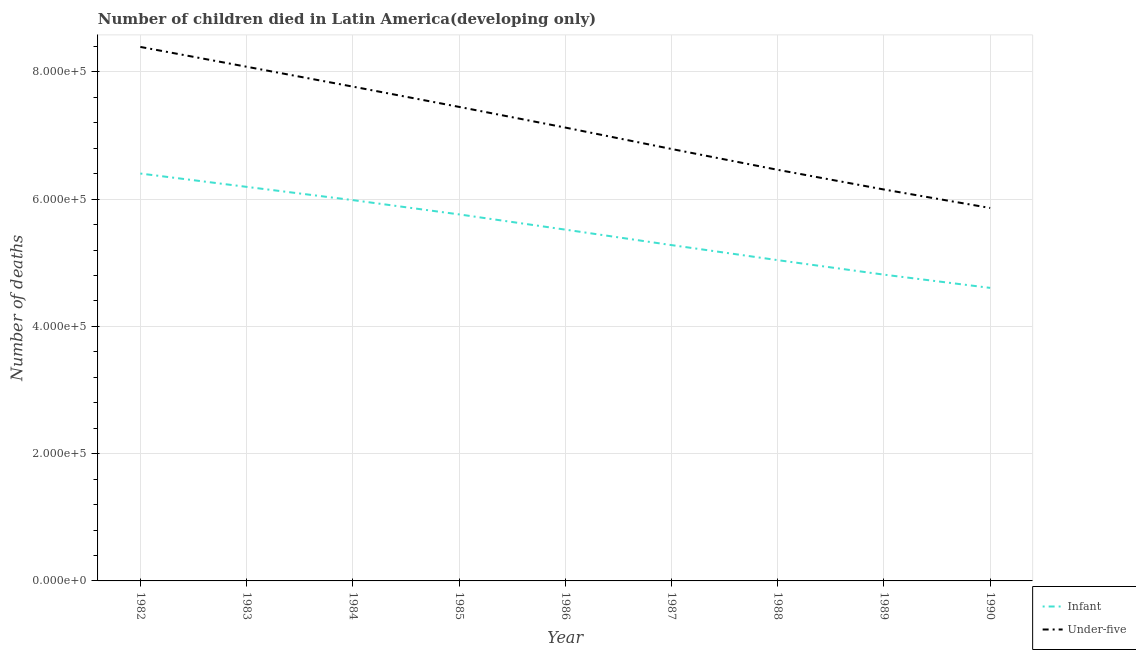How many different coloured lines are there?
Your response must be concise. 2. Does the line corresponding to number of infant deaths intersect with the line corresponding to number of under-five deaths?
Your response must be concise. No. What is the number of infant deaths in 1986?
Provide a short and direct response. 5.52e+05. Across all years, what is the maximum number of under-five deaths?
Offer a very short reply. 8.39e+05. Across all years, what is the minimum number of under-five deaths?
Offer a very short reply. 5.86e+05. In which year was the number of infant deaths minimum?
Provide a short and direct response. 1990. What is the total number of infant deaths in the graph?
Make the answer very short. 4.96e+06. What is the difference between the number of under-five deaths in 1983 and that in 1985?
Offer a terse response. 6.31e+04. What is the difference between the number of infant deaths in 1989 and the number of under-five deaths in 1988?
Give a very brief answer. -1.65e+05. What is the average number of infant deaths per year?
Keep it short and to the point. 5.51e+05. In the year 1984, what is the difference between the number of infant deaths and number of under-five deaths?
Your answer should be compact. -1.78e+05. In how many years, is the number of infant deaths greater than 400000?
Ensure brevity in your answer.  9. What is the ratio of the number of infant deaths in 1986 to that in 1990?
Offer a terse response. 1.2. Is the number of under-five deaths in 1985 less than that in 1988?
Provide a succinct answer. No. Is the difference between the number of under-five deaths in 1983 and 1985 greater than the difference between the number of infant deaths in 1983 and 1985?
Keep it short and to the point. Yes. What is the difference between the highest and the second highest number of under-five deaths?
Provide a succinct answer. 3.11e+04. What is the difference between the highest and the lowest number of under-five deaths?
Your answer should be compact. 2.53e+05. In how many years, is the number of infant deaths greater than the average number of infant deaths taken over all years?
Provide a succinct answer. 5. Does the number of infant deaths monotonically increase over the years?
Your answer should be very brief. No. How many lines are there?
Provide a succinct answer. 2. How many years are there in the graph?
Ensure brevity in your answer.  9. What is the difference between two consecutive major ticks on the Y-axis?
Offer a terse response. 2.00e+05. Are the values on the major ticks of Y-axis written in scientific E-notation?
Ensure brevity in your answer.  Yes. What is the title of the graph?
Ensure brevity in your answer.  Number of children died in Latin America(developing only). Does "Diesel" appear as one of the legend labels in the graph?
Ensure brevity in your answer.  No. What is the label or title of the X-axis?
Provide a succinct answer. Year. What is the label or title of the Y-axis?
Give a very brief answer. Number of deaths. What is the Number of deaths in Infant in 1982?
Offer a very short reply. 6.40e+05. What is the Number of deaths in Under-five in 1982?
Provide a short and direct response. 8.39e+05. What is the Number of deaths of Infant in 1983?
Keep it short and to the point. 6.19e+05. What is the Number of deaths of Under-five in 1983?
Provide a succinct answer. 8.08e+05. What is the Number of deaths in Infant in 1984?
Your answer should be very brief. 5.98e+05. What is the Number of deaths of Under-five in 1984?
Make the answer very short. 7.77e+05. What is the Number of deaths in Infant in 1985?
Your answer should be compact. 5.76e+05. What is the Number of deaths of Under-five in 1985?
Provide a succinct answer. 7.45e+05. What is the Number of deaths of Infant in 1986?
Keep it short and to the point. 5.52e+05. What is the Number of deaths of Under-five in 1986?
Offer a very short reply. 7.12e+05. What is the Number of deaths of Infant in 1987?
Ensure brevity in your answer.  5.28e+05. What is the Number of deaths in Under-five in 1987?
Provide a succinct answer. 6.79e+05. What is the Number of deaths of Infant in 1988?
Provide a short and direct response. 5.04e+05. What is the Number of deaths of Under-five in 1988?
Your response must be concise. 6.46e+05. What is the Number of deaths of Infant in 1989?
Give a very brief answer. 4.81e+05. What is the Number of deaths in Under-five in 1989?
Keep it short and to the point. 6.15e+05. What is the Number of deaths of Infant in 1990?
Offer a very short reply. 4.61e+05. What is the Number of deaths in Under-five in 1990?
Offer a terse response. 5.86e+05. Across all years, what is the maximum Number of deaths of Infant?
Make the answer very short. 6.40e+05. Across all years, what is the maximum Number of deaths in Under-five?
Ensure brevity in your answer.  8.39e+05. Across all years, what is the minimum Number of deaths in Infant?
Give a very brief answer. 4.61e+05. Across all years, what is the minimum Number of deaths of Under-five?
Provide a short and direct response. 5.86e+05. What is the total Number of deaths in Infant in the graph?
Your answer should be very brief. 4.96e+06. What is the total Number of deaths of Under-five in the graph?
Make the answer very short. 6.41e+06. What is the difference between the Number of deaths in Infant in 1982 and that in 1983?
Give a very brief answer. 2.09e+04. What is the difference between the Number of deaths of Under-five in 1982 and that in 1983?
Your answer should be compact. 3.11e+04. What is the difference between the Number of deaths of Infant in 1982 and that in 1984?
Make the answer very short. 4.18e+04. What is the difference between the Number of deaths in Under-five in 1982 and that in 1984?
Offer a very short reply. 6.24e+04. What is the difference between the Number of deaths in Infant in 1982 and that in 1985?
Give a very brief answer. 6.42e+04. What is the difference between the Number of deaths of Under-five in 1982 and that in 1985?
Your answer should be very brief. 9.42e+04. What is the difference between the Number of deaths of Infant in 1982 and that in 1986?
Your response must be concise. 8.81e+04. What is the difference between the Number of deaths in Under-five in 1982 and that in 1986?
Give a very brief answer. 1.27e+05. What is the difference between the Number of deaths of Infant in 1982 and that in 1987?
Your answer should be compact. 1.12e+05. What is the difference between the Number of deaths in Under-five in 1982 and that in 1987?
Keep it short and to the point. 1.60e+05. What is the difference between the Number of deaths of Infant in 1982 and that in 1988?
Ensure brevity in your answer.  1.36e+05. What is the difference between the Number of deaths of Under-five in 1982 and that in 1988?
Offer a terse response. 1.93e+05. What is the difference between the Number of deaths in Infant in 1982 and that in 1989?
Ensure brevity in your answer.  1.59e+05. What is the difference between the Number of deaths of Under-five in 1982 and that in 1989?
Offer a terse response. 2.24e+05. What is the difference between the Number of deaths in Infant in 1982 and that in 1990?
Provide a short and direct response. 1.80e+05. What is the difference between the Number of deaths of Under-five in 1982 and that in 1990?
Your answer should be very brief. 2.53e+05. What is the difference between the Number of deaths in Infant in 1983 and that in 1984?
Keep it short and to the point. 2.08e+04. What is the difference between the Number of deaths of Under-five in 1983 and that in 1984?
Offer a very short reply. 3.12e+04. What is the difference between the Number of deaths in Infant in 1983 and that in 1985?
Ensure brevity in your answer.  4.33e+04. What is the difference between the Number of deaths of Under-five in 1983 and that in 1985?
Give a very brief answer. 6.31e+04. What is the difference between the Number of deaths of Infant in 1983 and that in 1986?
Your answer should be very brief. 6.72e+04. What is the difference between the Number of deaths of Under-five in 1983 and that in 1986?
Provide a short and direct response. 9.56e+04. What is the difference between the Number of deaths of Infant in 1983 and that in 1987?
Keep it short and to the point. 9.15e+04. What is the difference between the Number of deaths of Under-five in 1983 and that in 1987?
Ensure brevity in your answer.  1.29e+05. What is the difference between the Number of deaths in Infant in 1983 and that in 1988?
Provide a succinct answer. 1.15e+05. What is the difference between the Number of deaths of Under-five in 1983 and that in 1988?
Your answer should be very brief. 1.62e+05. What is the difference between the Number of deaths in Infant in 1983 and that in 1989?
Your answer should be compact. 1.38e+05. What is the difference between the Number of deaths in Under-five in 1983 and that in 1989?
Your answer should be compact. 1.93e+05. What is the difference between the Number of deaths of Infant in 1983 and that in 1990?
Keep it short and to the point. 1.59e+05. What is the difference between the Number of deaths in Under-five in 1983 and that in 1990?
Make the answer very short. 2.22e+05. What is the difference between the Number of deaths of Infant in 1984 and that in 1985?
Your response must be concise. 2.24e+04. What is the difference between the Number of deaths in Under-five in 1984 and that in 1985?
Your answer should be very brief. 3.19e+04. What is the difference between the Number of deaths of Infant in 1984 and that in 1986?
Provide a short and direct response. 4.64e+04. What is the difference between the Number of deaths of Under-five in 1984 and that in 1986?
Your response must be concise. 6.44e+04. What is the difference between the Number of deaths of Infant in 1984 and that in 1987?
Your response must be concise. 7.07e+04. What is the difference between the Number of deaths in Under-five in 1984 and that in 1987?
Your response must be concise. 9.80e+04. What is the difference between the Number of deaths in Infant in 1984 and that in 1988?
Make the answer very short. 9.43e+04. What is the difference between the Number of deaths of Under-five in 1984 and that in 1988?
Keep it short and to the point. 1.31e+05. What is the difference between the Number of deaths in Infant in 1984 and that in 1989?
Provide a short and direct response. 1.17e+05. What is the difference between the Number of deaths in Under-five in 1984 and that in 1989?
Your answer should be compact. 1.62e+05. What is the difference between the Number of deaths of Infant in 1984 and that in 1990?
Your answer should be compact. 1.38e+05. What is the difference between the Number of deaths in Under-five in 1984 and that in 1990?
Your response must be concise. 1.91e+05. What is the difference between the Number of deaths of Infant in 1985 and that in 1986?
Provide a succinct answer. 2.39e+04. What is the difference between the Number of deaths of Under-five in 1985 and that in 1986?
Provide a short and direct response. 3.25e+04. What is the difference between the Number of deaths of Infant in 1985 and that in 1987?
Provide a succinct answer. 4.83e+04. What is the difference between the Number of deaths in Under-five in 1985 and that in 1987?
Offer a terse response. 6.62e+04. What is the difference between the Number of deaths in Infant in 1985 and that in 1988?
Ensure brevity in your answer.  7.19e+04. What is the difference between the Number of deaths in Under-five in 1985 and that in 1988?
Your answer should be very brief. 9.89e+04. What is the difference between the Number of deaths in Infant in 1985 and that in 1989?
Provide a short and direct response. 9.47e+04. What is the difference between the Number of deaths of Under-five in 1985 and that in 1989?
Keep it short and to the point. 1.30e+05. What is the difference between the Number of deaths of Infant in 1985 and that in 1990?
Offer a terse response. 1.16e+05. What is the difference between the Number of deaths of Under-five in 1985 and that in 1990?
Your answer should be compact. 1.59e+05. What is the difference between the Number of deaths in Infant in 1986 and that in 1987?
Give a very brief answer. 2.43e+04. What is the difference between the Number of deaths of Under-five in 1986 and that in 1987?
Provide a short and direct response. 3.37e+04. What is the difference between the Number of deaths in Infant in 1986 and that in 1988?
Your response must be concise. 4.80e+04. What is the difference between the Number of deaths in Under-five in 1986 and that in 1988?
Provide a succinct answer. 6.64e+04. What is the difference between the Number of deaths of Infant in 1986 and that in 1989?
Provide a short and direct response. 7.08e+04. What is the difference between the Number of deaths of Under-five in 1986 and that in 1989?
Provide a short and direct response. 9.73e+04. What is the difference between the Number of deaths of Infant in 1986 and that in 1990?
Offer a terse response. 9.16e+04. What is the difference between the Number of deaths in Under-five in 1986 and that in 1990?
Make the answer very short. 1.26e+05. What is the difference between the Number of deaths in Infant in 1987 and that in 1988?
Provide a succinct answer. 2.36e+04. What is the difference between the Number of deaths in Under-five in 1987 and that in 1988?
Keep it short and to the point. 3.27e+04. What is the difference between the Number of deaths in Infant in 1987 and that in 1989?
Provide a succinct answer. 4.64e+04. What is the difference between the Number of deaths in Under-five in 1987 and that in 1989?
Your answer should be compact. 6.37e+04. What is the difference between the Number of deaths of Infant in 1987 and that in 1990?
Provide a succinct answer. 6.72e+04. What is the difference between the Number of deaths in Under-five in 1987 and that in 1990?
Offer a very short reply. 9.27e+04. What is the difference between the Number of deaths in Infant in 1988 and that in 1989?
Offer a very short reply. 2.28e+04. What is the difference between the Number of deaths in Under-five in 1988 and that in 1989?
Your response must be concise. 3.09e+04. What is the difference between the Number of deaths in Infant in 1988 and that in 1990?
Ensure brevity in your answer.  4.36e+04. What is the difference between the Number of deaths in Under-five in 1988 and that in 1990?
Provide a short and direct response. 6.00e+04. What is the difference between the Number of deaths of Infant in 1989 and that in 1990?
Make the answer very short. 2.08e+04. What is the difference between the Number of deaths in Under-five in 1989 and that in 1990?
Your answer should be very brief. 2.90e+04. What is the difference between the Number of deaths of Infant in 1982 and the Number of deaths of Under-five in 1983?
Offer a very short reply. -1.68e+05. What is the difference between the Number of deaths of Infant in 1982 and the Number of deaths of Under-five in 1984?
Ensure brevity in your answer.  -1.37e+05. What is the difference between the Number of deaths in Infant in 1982 and the Number of deaths in Under-five in 1985?
Make the answer very short. -1.05e+05. What is the difference between the Number of deaths in Infant in 1982 and the Number of deaths in Under-five in 1986?
Provide a short and direct response. -7.22e+04. What is the difference between the Number of deaths of Infant in 1982 and the Number of deaths of Under-five in 1987?
Your response must be concise. -3.86e+04. What is the difference between the Number of deaths of Infant in 1982 and the Number of deaths of Under-five in 1988?
Give a very brief answer. -5852. What is the difference between the Number of deaths in Infant in 1982 and the Number of deaths in Under-five in 1989?
Keep it short and to the point. 2.51e+04. What is the difference between the Number of deaths of Infant in 1982 and the Number of deaths of Under-five in 1990?
Give a very brief answer. 5.41e+04. What is the difference between the Number of deaths of Infant in 1983 and the Number of deaths of Under-five in 1984?
Your response must be concise. -1.58e+05. What is the difference between the Number of deaths in Infant in 1983 and the Number of deaths in Under-five in 1985?
Your response must be concise. -1.26e+05. What is the difference between the Number of deaths in Infant in 1983 and the Number of deaths in Under-five in 1986?
Offer a terse response. -9.32e+04. What is the difference between the Number of deaths in Infant in 1983 and the Number of deaths in Under-five in 1987?
Offer a very short reply. -5.95e+04. What is the difference between the Number of deaths in Infant in 1983 and the Number of deaths in Under-five in 1988?
Your response must be concise. -2.68e+04. What is the difference between the Number of deaths in Infant in 1983 and the Number of deaths in Under-five in 1989?
Offer a terse response. 4158. What is the difference between the Number of deaths in Infant in 1983 and the Number of deaths in Under-five in 1990?
Provide a succinct answer. 3.32e+04. What is the difference between the Number of deaths of Infant in 1984 and the Number of deaths of Under-five in 1985?
Give a very brief answer. -1.47e+05. What is the difference between the Number of deaths of Infant in 1984 and the Number of deaths of Under-five in 1986?
Provide a short and direct response. -1.14e+05. What is the difference between the Number of deaths in Infant in 1984 and the Number of deaths in Under-five in 1987?
Your answer should be very brief. -8.03e+04. What is the difference between the Number of deaths of Infant in 1984 and the Number of deaths of Under-five in 1988?
Offer a very short reply. -4.76e+04. What is the difference between the Number of deaths of Infant in 1984 and the Number of deaths of Under-five in 1989?
Keep it short and to the point. -1.67e+04. What is the difference between the Number of deaths in Infant in 1984 and the Number of deaths in Under-five in 1990?
Provide a succinct answer. 1.24e+04. What is the difference between the Number of deaths in Infant in 1985 and the Number of deaths in Under-five in 1986?
Make the answer very short. -1.36e+05. What is the difference between the Number of deaths in Infant in 1985 and the Number of deaths in Under-five in 1987?
Your answer should be compact. -1.03e+05. What is the difference between the Number of deaths of Infant in 1985 and the Number of deaths of Under-five in 1988?
Offer a terse response. -7.00e+04. What is the difference between the Number of deaths in Infant in 1985 and the Number of deaths in Under-five in 1989?
Your answer should be very brief. -3.91e+04. What is the difference between the Number of deaths of Infant in 1985 and the Number of deaths of Under-five in 1990?
Offer a terse response. -1.01e+04. What is the difference between the Number of deaths of Infant in 1986 and the Number of deaths of Under-five in 1987?
Offer a terse response. -1.27e+05. What is the difference between the Number of deaths of Infant in 1986 and the Number of deaths of Under-five in 1988?
Offer a terse response. -9.40e+04. What is the difference between the Number of deaths of Infant in 1986 and the Number of deaths of Under-five in 1989?
Give a very brief answer. -6.30e+04. What is the difference between the Number of deaths in Infant in 1986 and the Number of deaths in Under-five in 1990?
Give a very brief answer. -3.40e+04. What is the difference between the Number of deaths in Infant in 1987 and the Number of deaths in Under-five in 1988?
Give a very brief answer. -1.18e+05. What is the difference between the Number of deaths of Infant in 1987 and the Number of deaths of Under-five in 1989?
Give a very brief answer. -8.74e+04. What is the difference between the Number of deaths of Infant in 1987 and the Number of deaths of Under-five in 1990?
Your answer should be compact. -5.83e+04. What is the difference between the Number of deaths of Infant in 1988 and the Number of deaths of Under-five in 1989?
Your response must be concise. -1.11e+05. What is the difference between the Number of deaths of Infant in 1988 and the Number of deaths of Under-five in 1990?
Give a very brief answer. -8.20e+04. What is the difference between the Number of deaths of Infant in 1989 and the Number of deaths of Under-five in 1990?
Keep it short and to the point. -1.05e+05. What is the average Number of deaths of Infant per year?
Your response must be concise. 5.51e+05. What is the average Number of deaths of Under-five per year?
Give a very brief answer. 7.12e+05. In the year 1982, what is the difference between the Number of deaths in Infant and Number of deaths in Under-five?
Make the answer very short. -1.99e+05. In the year 1983, what is the difference between the Number of deaths in Infant and Number of deaths in Under-five?
Your response must be concise. -1.89e+05. In the year 1984, what is the difference between the Number of deaths in Infant and Number of deaths in Under-five?
Your answer should be very brief. -1.78e+05. In the year 1985, what is the difference between the Number of deaths in Infant and Number of deaths in Under-five?
Provide a succinct answer. -1.69e+05. In the year 1986, what is the difference between the Number of deaths in Infant and Number of deaths in Under-five?
Keep it short and to the point. -1.60e+05. In the year 1987, what is the difference between the Number of deaths in Infant and Number of deaths in Under-five?
Offer a very short reply. -1.51e+05. In the year 1988, what is the difference between the Number of deaths of Infant and Number of deaths of Under-five?
Offer a very short reply. -1.42e+05. In the year 1989, what is the difference between the Number of deaths in Infant and Number of deaths in Under-five?
Your answer should be compact. -1.34e+05. In the year 1990, what is the difference between the Number of deaths of Infant and Number of deaths of Under-five?
Give a very brief answer. -1.26e+05. What is the ratio of the Number of deaths of Infant in 1982 to that in 1983?
Give a very brief answer. 1.03. What is the ratio of the Number of deaths in Infant in 1982 to that in 1984?
Offer a very short reply. 1.07. What is the ratio of the Number of deaths in Under-five in 1982 to that in 1984?
Your answer should be very brief. 1.08. What is the ratio of the Number of deaths of Infant in 1982 to that in 1985?
Your answer should be very brief. 1.11. What is the ratio of the Number of deaths of Under-five in 1982 to that in 1985?
Your answer should be compact. 1.13. What is the ratio of the Number of deaths in Infant in 1982 to that in 1986?
Keep it short and to the point. 1.16. What is the ratio of the Number of deaths in Under-five in 1982 to that in 1986?
Make the answer very short. 1.18. What is the ratio of the Number of deaths of Infant in 1982 to that in 1987?
Your answer should be very brief. 1.21. What is the ratio of the Number of deaths of Under-five in 1982 to that in 1987?
Make the answer very short. 1.24. What is the ratio of the Number of deaths in Infant in 1982 to that in 1988?
Offer a terse response. 1.27. What is the ratio of the Number of deaths of Under-five in 1982 to that in 1988?
Ensure brevity in your answer.  1.3. What is the ratio of the Number of deaths in Infant in 1982 to that in 1989?
Your answer should be compact. 1.33. What is the ratio of the Number of deaths of Under-five in 1982 to that in 1989?
Provide a short and direct response. 1.36. What is the ratio of the Number of deaths of Infant in 1982 to that in 1990?
Give a very brief answer. 1.39. What is the ratio of the Number of deaths of Under-five in 1982 to that in 1990?
Make the answer very short. 1.43. What is the ratio of the Number of deaths of Infant in 1983 to that in 1984?
Provide a succinct answer. 1.03. What is the ratio of the Number of deaths of Under-five in 1983 to that in 1984?
Ensure brevity in your answer.  1.04. What is the ratio of the Number of deaths in Infant in 1983 to that in 1985?
Provide a succinct answer. 1.08. What is the ratio of the Number of deaths of Under-five in 1983 to that in 1985?
Your answer should be compact. 1.08. What is the ratio of the Number of deaths of Infant in 1983 to that in 1986?
Offer a terse response. 1.12. What is the ratio of the Number of deaths in Under-five in 1983 to that in 1986?
Your answer should be very brief. 1.13. What is the ratio of the Number of deaths in Infant in 1983 to that in 1987?
Provide a succinct answer. 1.17. What is the ratio of the Number of deaths in Under-five in 1983 to that in 1987?
Offer a terse response. 1.19. What is the ratio of the Number of deaths of Infant in 1983 to that in 1988?
Ensure brevity in your answer.  1.23. What is the ratio of the Number of deaths in Under-five in 1983 to that in 1988?
Make the answer very short. 1.25. What is the ratio of the Number of deaths in Infant in 1983 to that in 1989?
Ensure brevity in your answer.  1.29. What is the ratio of the Number of deaths in Under-five in 1983 to that in 1989?
Ensure brevity in your answer.  1.31. What is the ratio of the Number of deaths of Infant in 1983 to that in 1990?
Provide a short and direct response. 1.34. What is the ratio of the Number of deaths of Under-five in 1983 to that in 1990?
Offer a terse response. 1.38. What is the ratio of the Number of deaths in Infant in 1984 to that in 1985?
Your answer should be very brief. 1.04. What is the ratio of the Number of deaths in Under-five in 1984 to that in 1985?
Keep it short and to the point. 1.04. What is the ratio of the Number of deaths in Infant in 1984 to that in 1986?
Provide a short and direct response. 1.08. What is the ratio of the Number of deaths in Under-five in 1984 to that in 1986?
Your response must be concise. 1.09. What is the ratio of the Number of deaths of Infant in 1984 to that in 1987?
Ensure brevity in your answer.  1.13. What is the ratio of the Number of deaths of Under-five in 1984 to that in 1987?
Your answer should be compact. 1.14. What is the ratio of the Number of deaths in Infant in 1984 to that in 1988?
Your response must be concise. 1.19. What is the ratio of the Number of deaths of Under-five in 1984 to that in 1988?
Provide a short and direct response. 1.2. What is the ratio of the Number of deaths of Infant in 1984 to that in 1989?
Offer a very short reply. 1.24. What is the ratio of the Number of deaths in Under-five in 1984 to that in 1989?
Your answer should be compact. 1.26. What is the ratio of the Number of deaths of Infant in 1984 to that in 1990?
Your response must be concise. 1.3. What is the ratio of the Number of deaths in Under-five in 1984 to that in 1990?
Your response must be concise. 1.33. What is the ratio of the Number of deaths of Infant in 1985 to that in 1986?
Keep it short and to the point. 1.04. What is the ratio of the Number of deaths in Under-five in 1985 to that in 1986?
Offer a very short reply. 1.05. What is the ratio of the Number of deaths of Infant in 1985 to that in 1987?
Provide a short and direct response. 1.09. What is the ratio of the Number of deaths of Under-five in 1985 to that in 1987?
Keep it short and to the point. 1.1. What is the ratio of the Number of deaths of Infant in 1985 to that in 1988?
Offer a terse response. 1.14. What is the ratio of the Number of deaths in Under-five in 1985 to that in 1988?
Your response must be concise. 1.15. What is the ratio of the Number of deaths in Infant in 1985 to that in 1989?
Make the answer very short. 1.2. What is the ratio of the Number of deaths of Under-five in 1985 to that in 1989?
Your response must be concise. 1.21. What is the ratio of the Number of deaths of Infant in 1985 to that in 1990?
Ensure brevity in your answer.  1.25. What is the ratio of the Number of deaths in Under-five in 1985 to that in 1990?
Provide a short and direct response. 1.27. What is the ratio of the Number of deaths of Infant in 1986 to that in 1987?
Give a very brief answer. 1.05. What is the ratio of the Number of deaths of Under-five in 1986 to that in 1987?
Give a very brief answer. 1.05. What is the ratio of the Number of deaths in Infant in 1986 to that in 1988?
Give a very brief answer. 1.1. What is the ratio of the Number of deaths of Under-five in 1986 to that in 1988?
Your answer should be very brief. 1.1. What is the ratio of the Number of deaths of Infant in 1986 to that in 1989?
Ensure brevity in your answer.  1.15. What is the ratio of the Number of deaths of Under-five in 1986 to that in 1989?
Provide a succinct answer. 1.16. What is the ratio of the Number of deaths of Infant in 1986 to that in 1990?
Keep it short and to the point. 1.2. What is the ratio of the Number of deaths in Under-five in 1986 to that in 1990?
Make the answer very short. 1.22. What is the ratio of the Number of deaths of Infant in 1987 to that in 1988?
Provide a succinct answer. 1.05. What is the ratio of the Number of deaths of Under-five in 1987 to that in 1988?
Offer a terse response. 1.05. What is the ratio of the Number of deaths of Infant in 1987 to that in 1989?
Your answer should be compact. 1.1. What is the ratio of the Number of deaths in Under-five in 1987 to that in 1989?
Offer a very short reply. 1.1. What is the ratio of the Number of deaths of Infant in 1987 to that in 1990?
Offer a very short reply. 1.15. What is the ratio of the Number of deaths in Under-five in 1987 to that in 1990?
Make the answer very short. 1.16. What is the ratio of the Number of deaths of Infant in 1988 to that in 1989?
Make the answer very short. 1.05. What is the ratio of the Number of deaths of Under-five in 1988 to that in 1989?
Make the answer very short. 1.05. What is the ratio of the Number of deaths in Infant in 1988 to that in 1990?
Give a very brief answer. 1.09. What is the ratio of the Number of deaths in Under-five in 1988 to that in 1990?
Provide a short and direct response. 1.1. What is the ratio of the Number of deaths of Infant in 1989 to that in 1990?
Ensure brevity in your answer.  1.05. What is the ratio of the Number of deaths in Under-five in 1989 to that in 1990?
Your response must be concise. 1.05. What is the difference between the highest and the second highest Number of deaths of Infant?
Give a very brief answer. 2.09e+04. What is the difference between the highest and the second highest Number of deaths in Under-five?
Give a very brief answer. 3.11e+04. What is the difference between the highest and the lowest Number of deaths in Infant?
Provide a short and direct response. 1.80e+05. What is the difference between the highest and the lowest Number of deaths in Under-five?
Offer a very short reply. 2.53e+05. 